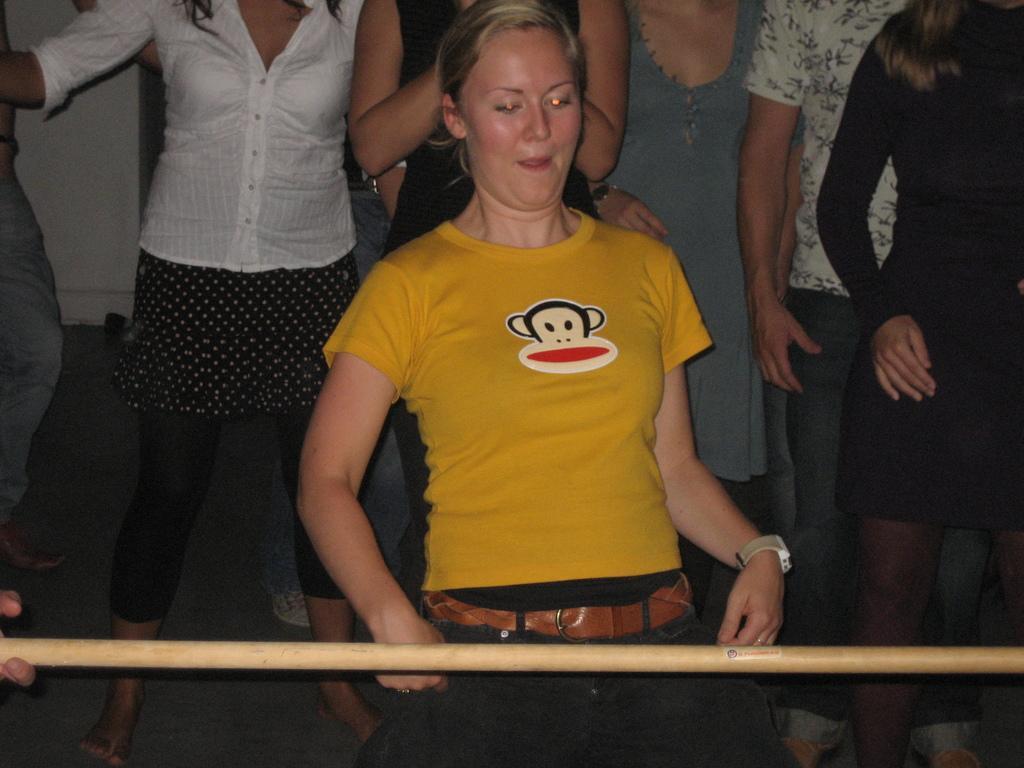How would you summarize this image in a sentence or two? In this picture I can see a woman standing, there is a wooden stick, and in the background there are group of people standing. 